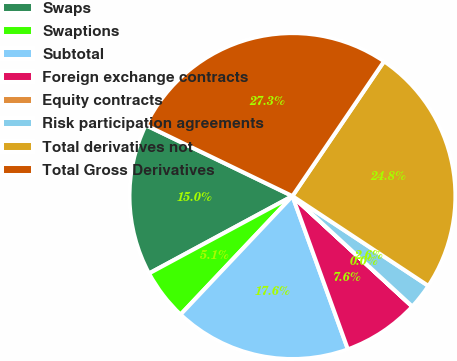Convert chart. <chart><loc_0><loc_0><loc_500><loc_500><pie_chart><fcel>Swaps<fcel>Swaptions<fcel>Subtotal<fcel>Foreign exchange contracts<fcel>Equity contracts<fcel>Risk participation agreements<fcel>Total derivatives not<fcel>Total Gross Derivatives<nl><fcel>15.04%<fcel>5.08%<fcel>17.57%<fcel>7.62%<fcel>0.01%<fcel>2.55%<fcel>24.79%<fcel>27.33%<nl></chart> 